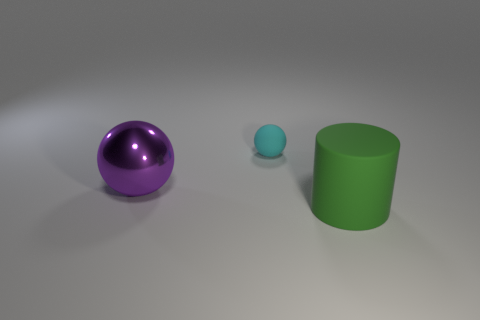Is there anything else that has the same size as the cyan thing?
Give a very brief answer. No. What size is the matte thing that is behind the large object that is to the right of the big thing that is left of the green object?
Make the answer very short. Small. What number of large purple balls are behind the matte object that is left of the rubber cylinder?
Provide a succinct answer. 0. How big is the thing that is both behind the big green rubber thing and to the right of the metallic ball?
Provide a short and direct response. Small. What number of metal things are large cyan objects or big cylinders?
Make the answer very short. 0. What is the material of the cylinder?
Your answer should be very brief. Rubber. What material is the big object behind the object that is right of the thing behind the big purple ball?
Give a very brief answer. Metal. The other object that is the same size as the green object is what shape?
Offer a very short reply. Sphere. How many objects are either tiny metal balls or matte objects in front of the large metal ball?
Ensure brevity in your answer.  1. Do the thing in front of the shiny ball and the large thing behind the big cylinder have the same material?
Give a very brief answer. No. 